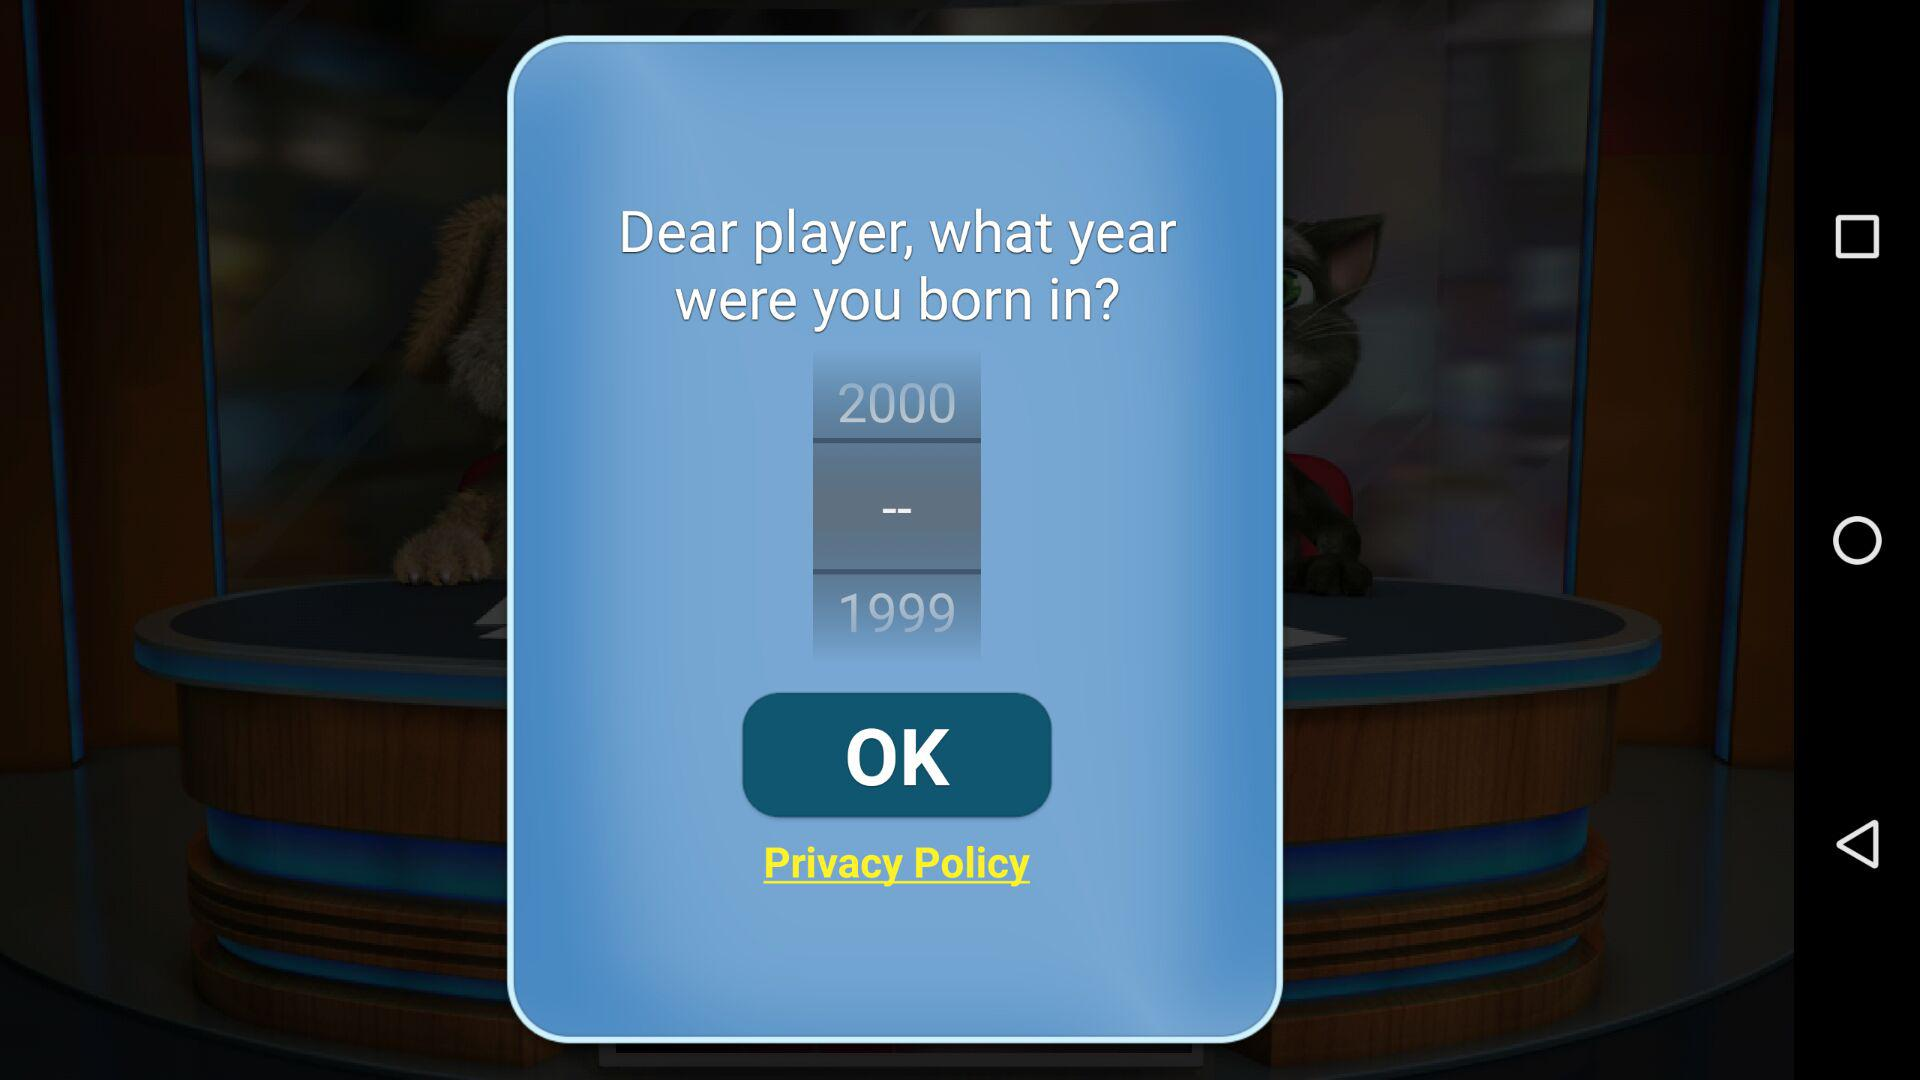How many years are available to choose from?
Answer the question using a single word or phrase. 2 